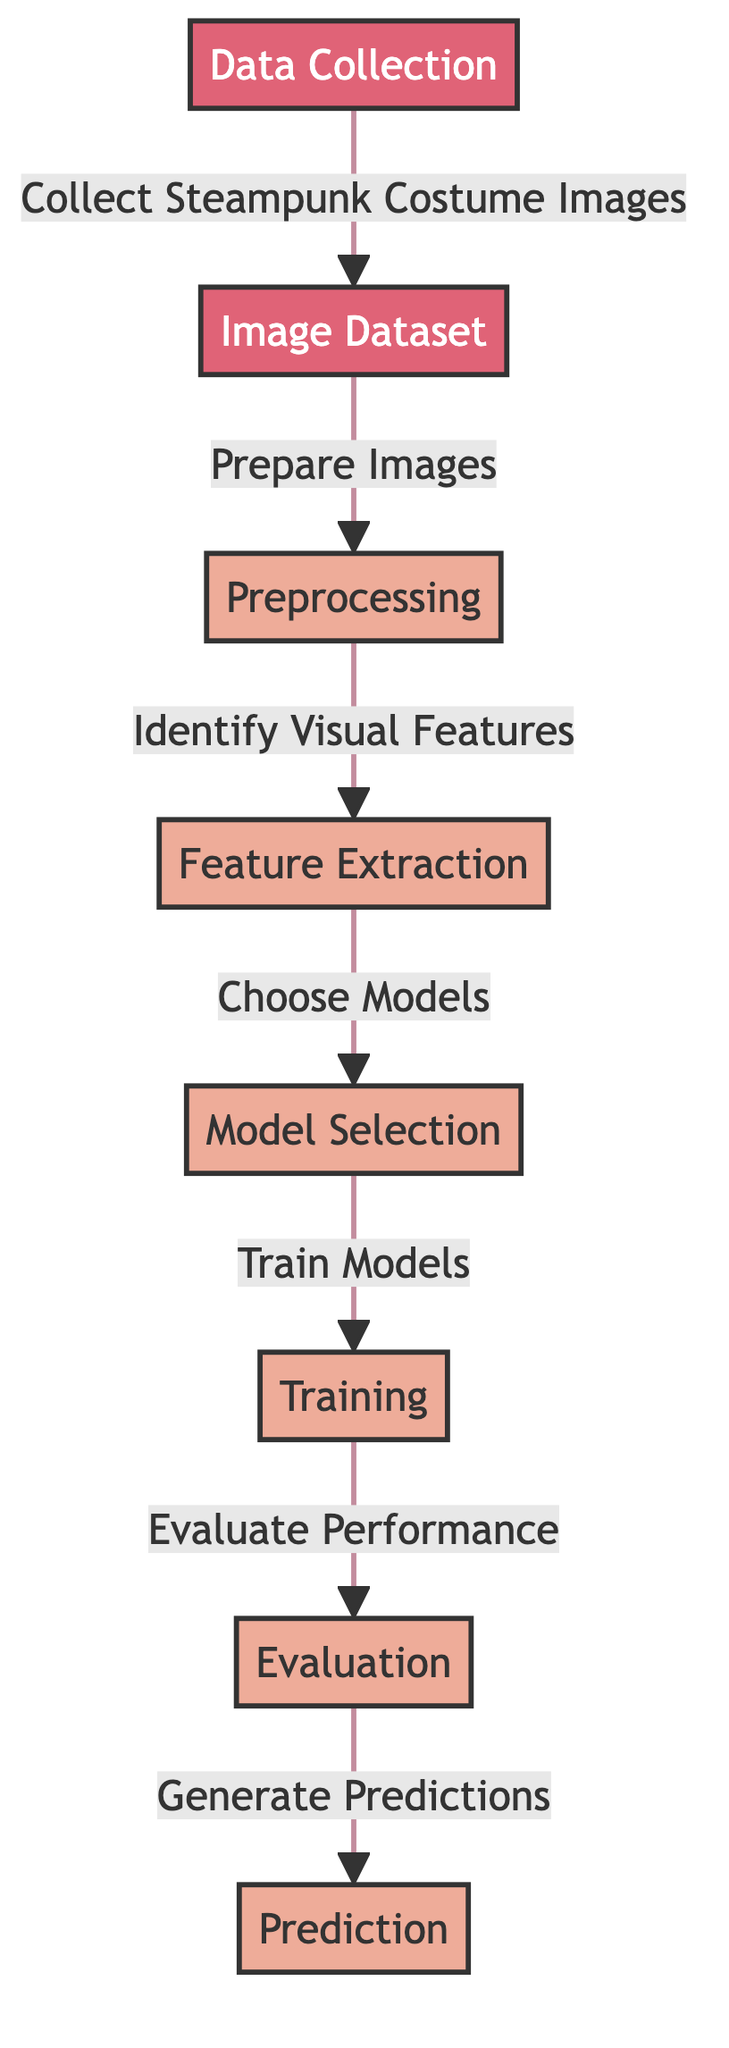What is the first step in the diagram? The first step in the diagram is "Data Collection," which indicates the initial phase where images of steampunk costumes are gathered.
Answer: Data Collection How many processes are involved in this diagram? There are five processes indicated in the diagram: Preprocessing, Feature Extraction, Model Selection, Training, and Evaluation.
Answer: Five What follows after the "Image Dataset" node? The node that follows "Image Dataset" is "Preprocessing," meaning the images are prepared after collecting the dataset.
Answer: Preprocessing Which node is related to model performance assessment? The "Evaluation" node is specifically related to assessing the performance of the model after it has been trained.
Answer: Evaluation What type of images are collected in the Data Collection step? The images collected in the Data Collection step are "Steampunk Costume Images," specifically targeting the thematic costume elements for the event.
Answer: Steampunk Costume Images What step occurs after "Feature Extraction"? The step that occurs after "Feature Extraction" is "Model Selection," where different models are chosen for the classification task.
Answer: Model Selection What is the final output of the process shown in the diagram? The final output of the process is "Prediction," which is the result generated after evaluating the model’s performance.
Answer: Prediction How does "Image Dataset" relate to "Data Collection"? "Image Dataset" is a direct result of "Data Collection," as images collected will form the dataset that is prepared for further processing.
Answer: Direct result What is the purpose of the "Training" step? The purpose of the "Training" step is to utilize the selected models to learn from the data and improve predictive accuracy.
Answer: To learn from data 